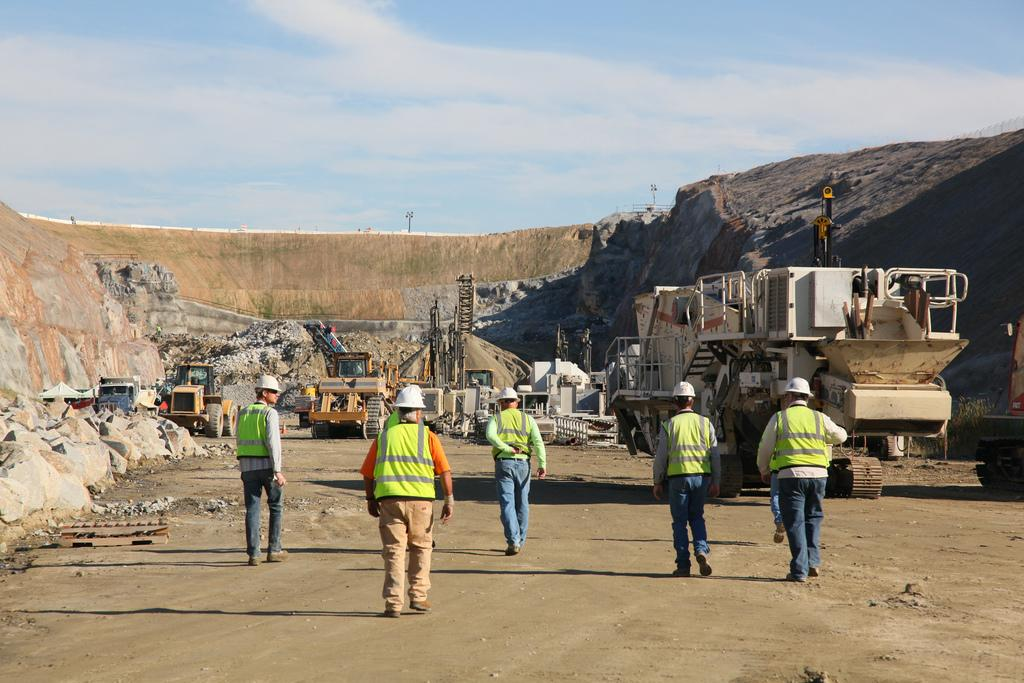Who or what can be seen in the image? There are people and vehicles in the image. What type of objects are present in the image? There are rocks in the image. What can be seen in the background of the image? The sky and poles are visible in the background of the image. What type of spoon is being used by the actor in the image? There is no actor or spoon present in the image. What type of mailbox can be seen near the rocks in the image? There is no mailbox present in the image; only people, vehicles, rocks, the sky, and poles are visible. 